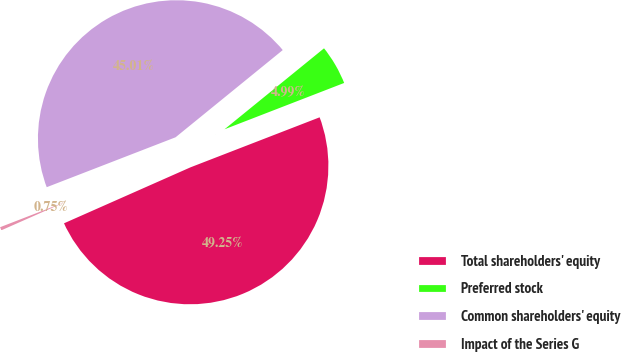<chart> <loc_0><loc_0><loc_500><loc_500><pie_chart><fcel>Total shareholders' equity<fcel>Preferred stock<fcel>Common shareholders' equity<fcel>Impact of the Series G<nl><fcel>49.25%<fcel>4.99%<fcel>45.01%<fcel>0.75%<nl></chart> 